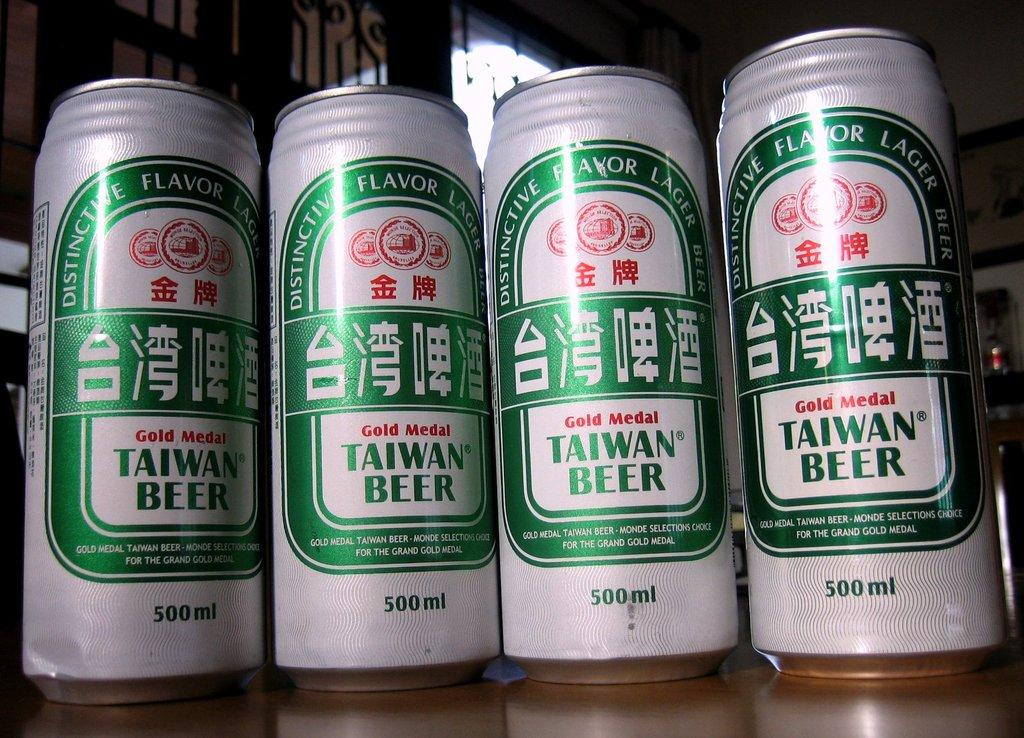What is the main subject in the center of the image? There are beer tins in the center of the image. What can be seen in the background of the image? There are windows in the background of the image. Where can the shop with fresh bread be found in the image? There is no shop or bread present in the image; it only features beer tins and windows. How many houses are visible in the image? There are no houses visible in the image; it only features beer tins and windows. 